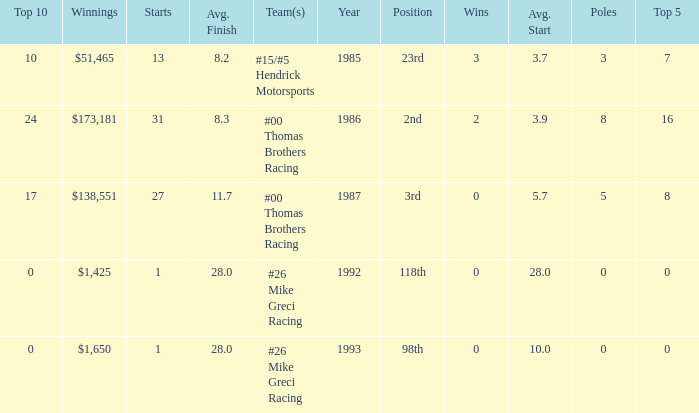How many years did he have an average finish of 11.7? 1.0. 